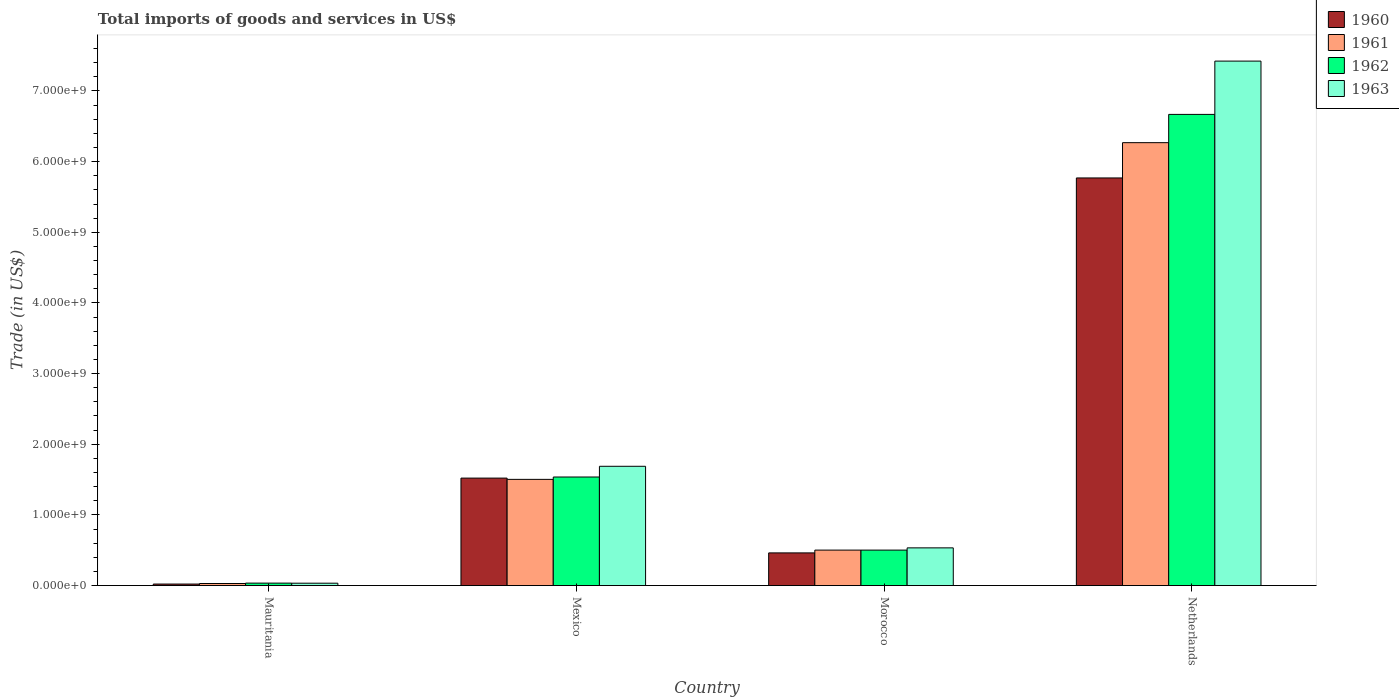How many different coloured bars are there?
Your answer should be compact. 4. How many groups of bars are there?
Your answer should be very brief. 4. Are the number of bars per tick equal to the number of legend labels?
Provide a short and direct response. Yes. Are the number of bars on each tick of the X-axis equal?
Offer a terse response. Yes. How many bars are there on the 2nd tick from the left?
Give a very brief answer. 4. What is the label of the 3rd group of bars from the left?
Provide a short and direct response. Morocco. What is the total imports of goods and services in 1962 in Netherlands?
Your answer should be compact. 6.67e+09. Across all countries, what is the maximum total imports of goods and services in 1963?
Make the answer very short. 7.42e+09. Across all countries, what is the minimum total imports of goods and services in 1962?
Your answer should be compact. 3.46e+07. In which country was the total imports of goods and services in 1961 minimum?
Give a very brief answer. Mauritania. What is the total total imports of goods and services in 1960 in the graph?
Make the answer very short. 7.77e+09. What is the difference between the total imports of goods and services in 1960 in Mauritania and that in Netherlands?
Provide a succinct answer. -5.75e+09. What is the difference between the total imports of goods and services in 1961 in Mauritania and the total imports of goods and services in 1960 in Netherlands?
Your answer should be very brief. -5.74e+09. What is the average total imports of goods and services in 1961 per country?
Your response must be concise. 2.08e+09. What is the difference between the total imports of goods and services of/in 1963 and total imports of goods and services of/in 1960 in Netherlands?
Offer a terse response. 1.65e+09. What is the ratio of the total imports of goods and services in 1963 in Morocco to that in Netherlands?
Ensure brevity in your answer.  0.07. Is the total imports of goods and services in 1961 in Mexico less than that in Netherlands?
Your response must be concise. Yes. Is the difference between the total imports of goods and services in 1963 in Mexico and Morocco greater than the difference between the total imports of goods and services in 1960 in Mexico and Morocco?
Keep it short and to the point. Yes. What is the difference between the highest and the second highest total imports of goods and services in 1963?
Offer a very short reply. -1.15e+09. What is the difference between the highest and the lowest total imports of goods and services in 1961?
Provide a succinct answer. 6.24e+09. In how many countries, is the total imports of goods and services in 1961 greater than the average total imports of goods and services in 1961 taken over all countries?
Keep it short and to the point. 1. How many bars are there?
Offer a very short reply. 16. Are all the bars in the graph horizontal?
Make the answer very short. No. How many countries are there in the graph?
Offer a very short reply. 4. What is the difference between two consecutive major ticks on the Y-axis?
Ensure brevity in your answer.  1.00e+09. What is the title of the graph?
Offer a terse response. Total imports of goods and services in US$. What is the label or title of the X-axis?
Keep it short and to the point. Country. What is the label or title of the Y-axis?
Provide a short and direct response. Trade (in US$). What is the Trade (in US$) in 1960 in Mauritania?
Offer a very short reply. 2.13e+07. What is the Trade (in US$) in 1961 in Mauritania?
Your answer should be compact. 2.91e+07. What is the Trade (in US$) in 1962 in Mauritania?
Keep it short and to the point. 3.46e+07. What is the Trade (in US$) of 1963 in Mauritania?
Ensure brevity in your answer.  3.36e+07. What is the Trade (in US$) in 1960 in Mexico?
Give a very brief answer. 1.52e+09. What is the Trade (in US$) in 1961 in Mexico?
Provide a short and direct response. 1.50e+09. What is the Trade (in US$) of 1962 in Mexico?
Your answer should be compact. 1.54e+09. What is the Trade (in US$) of 1963 in Mexico?
Your response must be concise. 1.69e+09. What is the Trade (in US$) of 1960 in Morocco?
Keep it short and to the point. 4.62e+08. What is the Trade (in US$) of 1961 in Morocco?
Ensure brevity in your answer.  5.02e+08. What is the Trade (in US$) of 1962 in Morocco?
Make the answer very short. 5.02e+08. What is the Trade (in US$) in 1963 in Morocco?
Offer a very short reply. 5.34e+08. What is the Trade (in US$) in 1960 in Netherlands?
Your answer should be compact. 5.77e+09. What is the Trade (in US$) in 1961 in Netherlands?
Provide a succinct answer. 6.27e+09. What is the Trade (in US$) of 1962 in Netherlands?
Ensure brevity in your answer.  6.67e+09. What is the Trade (in US$) in 1963 in Netherlands?
Give a very brief answer. 7.42e+09. Across all countries, what is the maximum Trade (in US$) of 1960?
Your response must be concise. 5.77e+09. Across all countries, what is the maximum Trade (in US$) in 1961?
Your response must be concise. 6.27e+09. Across all countries, what is the maximum Trade (in US$) in 1962?
Your answer should be very brief. 6.67e+09. Across all countries, what is the maximum Trade (in US$) of 1963?
Give a very brief answer. 7.42e+09. Across all countries, what is the minimum Trade (in US$) in 1960?
Offer a terse response. 2.13e+07. Across all countries, what is the minimum Trade (in US$) of 1961?
Provide a succinct answer. 2.91e+07. Across all countries, what is the minimum Trade (in US$) of 1962?
Give a very brief answer. 3.46e+07. Across all countries, what is the minimum Trade (in US$) in 1963?
Your response must be concise. 3.36e+07. What is the total Trade (in US$) in 1960 in the graph?
Give a very brief answer. 7.77e+09. What is the total Trade (in US$) of 1961 in the graph?
Your answer should be very brief. 8.30e+09. What is the total Trade (in US$) in 1962 in the graph?
Your answer should be very brief. 8.74e+09. What is the total Trade (in US$) in 1963 in the graph?
Give a very brief answer. 9.68e+09. What is the difference between the Trade (in US$) of 1960 in Mauritania and that in Mexico?
Provide a succinct answer. -1.50e+09. What is the difference between the Trade (in US$) of 1961 in Mauritania and that in Mexico?
Offer a terse response. -1.47e+09. What is the difference between the Trade (in US$) of 1962 in Mauritania and that in Mexico?
Your response must be concise. -1.50e+09. What is the difference between the Trade (in US$) in 1963 in Mauritania and that in Mexico?
Give a very brief answer. -1.65e+09. What is the difference between the Trade (in US$) in 1960 in Mauritania and that in Morocco?
Provide a succinct answer. -4.41e+08. What is the difference between the Trade (in US$) in 1961 in Mauritania and that in Morocco?
Offer a very short reply. -4.73e+08. What is the difference between the Trade (in US$) of 1962 in Mauritania and that in Morocco?
Provide a short and direct response. -4.67e+08. What is the difference between the Trade (in US$) in 1963 in Mauritania and that in Morocco?
Provide a short and direct response. -5.00e+08. What is the difference between the Trade (in US$) of 1960 in Mauritania and that in Netherlands?
Your response must be concise. -5.75e+09. What is the difference between the Trade (in US$) of 1961 in Mauritania and that in Netherlands?
Ensure brevity in your answer.  -6.24e+09. What is the difference between the Trade (in US$) of 1962 in Mauritania and that in Netherlands?
Provide a succinct answer. -6.63e+09. What is the difference between the Trade (in US$) of 1963 in Mauritania and that in Netherlands?
Make the answer very short. -7.39e+09. What is the difference between the Trade (in US$) of 1960 in Mexico and that in Morocco?
Your response must be concise. 1.06e+09. What is the difference between the Trade (in US$) of 1961 in Mexico and that in Morocco?
Your response must be concise. 1.00e+09. What is the difference between the Trade (in US$) in 1962 in Mexico and that in Morocco?
Make the answer very short. 1.03e+09. What is the difference between the Trade (in US$) of 1963 in Mexico and that in Morocco?
Provide a succinct answer. 1.15e+09. What is the difference between the Trade (in US$) in 1960 in Mexico and that in Netherlands?
Make the answer very short. -4.25e+09. What is the difference between the Trade (in US$) of 1961 in Mexico and that in Netherlands?
Offer a terse response. -4.77e+09. What is the difference between the Trade (in US$) in 1962 in Mexico and that in Netherlands?
Make the answer very short. -5.13e+09. What is the difference between the Trade (in US$) of 1963 in Mexico and that in Netherlands?
Ensure brevity in your answer.  -5.74e+09. What is the difference between the Trade (in US$) of 1960 in Morocco and that in Netherlands?
Your answer should be very brief. -5.31e+09. What is the difference between the Trade (in US$) in 1961 in Morocco and that in Netherlands?
Offer a very short reply. -5.77e+09. What is the difference between the Trade (in US$) of 1962 in Morocco and that in Netherlands?
Ensure brevity in your answer.  -6.17e+09. What is the difference between the Trade (in US$) of 1963 in Morocco and that in Netherlands?
Offer a very short reply. -6.89e+09. What is the difference between the Trade (in US$) of 1960 in Mauritania and the Trade (in US$) of 1961 in Mexico?
Ensure brevity in your answer.  -1.48e+09. What is the difference between the Trade (in US$) in 1960 in Mauritania and the Trade (in US$) in 1962 in Mexico?
Offer a terse response. -1.52e+09. What is the difference between the Trade (in US$) of 1960 in Mauritania and the Trade (in US$) of 1963 in Mexico?
Provide a succinct answer. -1.67e+09. What is the difference between the Trade (in US$) of 1961 in Mauritania and the Trade (in US$) of 1962 in Mexico?
Offer a terse response. -1.51e+09. What is the difference between the Trade (in US$) of 1961 in Mauritania and the Trade (in US$) of 1963 in Mexico?
Keep it short and to the point. -1.66e+09. What is the difference between the Trade (in US$) of 1962 in Mauritania and the Trade (in US$) of 1963 in Mexico?
Offer a terse response. -1.65e+09. What is the difference between the Trade (in US$) in 1960 in Mauritania and the Trade (in US$) in 1961 in Morocco?
Your answer should be very brief. -4.81e+08. What is the difference between the Trade (in US$) in 1960 in Mauritania and the Trade (in US$) in 1962 in Morocco?
Keep it short and to the point. -4.81e+08. What is the difference between the Trade (in US$) of 1960 in Mauritania and the Trade (in US$) of 1963 in Morocco?
Your response must be concise. -5.12e+08. What is the difference between the Trade (in US$) in 1961 in Mauritania and the Trade (in US$) in 1962 in Morocco?
Your answer should be very brief. -4.73e+08. What is the difference between the Trade (in US$) in 1961 in Mauritania and the Trade (in US$) in 1963 in Morocco?
Your answer should be compact. -5.04e+08. What is the difference between the Trade (in US$) of 1962 in Mauritania and the Trade (in US$) of 1963 in Morocco?
Give a very brief answer. -4.99e+08. What is the difference between the Trade (in US$) of 1960 in Mauritania and the Trade (in US$) of 1961 in Netherlands?
Keep it short and to the point. -6.25e+09. What is the difference between the Trade (in US$) in 1960 in Mauritania and the Trade (in US$) in 1962 in Netherlands?
Provide a succinct answer. -6.65e+09. What is the difference between the Trade (in US$) in 1960 in Mauritania and the Trade (in US$) in 1963 in Netherlands?
Offer a very short reply. -7.40e+09. What is the difference between the Trade (in US$) of 1961 in Mauritania and the Trade (in US$) of 1962 in Netherlands?
Keep it short and to the point. -6.64e+09. What is the difference between the Trade (in US$) in 1961 in Mauritania and the Trade (in US$) in 1963 in Netherlands?
Provide a short and direct response. -7.39e+09. What is the difference between the Trade (in US$) of 1962 in Mauritania and the Trade (in US$) of 1963 in Netherlands?
Your answer should be compact. -7.39e+09. What is the difference between the Trade (in US$) in 1960 in Mexico and the Trade (in US$) in 1961 in Morocco?
Your answer should be very brief. 1.02e+09. What is the difference between the Trade (in US$) of 1960 in Mexico and the Trade (in US$) of 1962 in Morocco?
Your answer should be very brief. 1.02e+09. What is the difference between the Trade (in US$) of 1960 in Mexico and the Trade (in US$) of 1963 in Morocco?
Offer a very short reply. 9.87e+08. What is the difference between the Trade (in US$) of 1961 in Mexico and the Trade (in US$) of 1962 in Morocco?
Provide a succinct answer. 1.00e+09. What is the difference between the Trade (in US$) of 1961 in Mexico and the Trade (in US$) of 1963 in Morocco?
Your response must be concise. 9.70e+08. What is the difference between the Trade (in US$) of 1962 in Mexico and the Trade (in US$) of 1963 in Morocco?
Keep it short and to the point. 1.00e+09. What is the difference between the Trade (in US$) of 1960 in Mexico and the Trade (in US$) of 1961 in Netherlands?
Ensure brevity in your answer.  -4.75e+09. What is the difference between the Trade (in US$) in 1960 in Mexico and the Trade (in US$) in 1962 in Netherlands?
Provide a succinct answer. -5.15e+09. What is the difference between the Trade (in US$) in 1960 in Mexico and the Trade (in US$) in 1963 in Netherlands?
Provide a short and direct response. -5.90e+09. What is the difference between the Trade (in US$) of 1961 in Mexico and the Trade (in US$) of 1962 in Netherlands?
Provide a succinct answer. -5.17e+09. What is the difference between the Trade (in US$) in 1961 in Mexico and the Trade (in US$) in 1963 in Netherlands?
Offer a very short reply. -5.92e+09. What is the difference between the Trade (in US$) in 1962 in Mexico and the Trade (in US$) in 1963 in Netherlands?
Provide a succinct answer. -5.89e+09. What is the difference between the Trade (in US$) in 1960 in Morocco and the Trade (in US$) in 1961 in Netherlands?
Make the answer very short. -5.81e+09. What is the difference between the Trade (in US$) in 1960 in Morocco and the Trade (in US$) in 1962 in Netherlands?
Give a very brief answer. -6.21e+09. What is the difference between the Trade (in US$) of 1960 in Morocco and the Trade (in US$) of 1963 in Netherlands?
Offer a very short reply. -6.96e+09. What is the difference between the Trade (in US$) of 1961 in Morocco and the Trade (in US$) of 1962 in Netherlands?
Give a very brief answer. -6.17e+09. What is the difference between the Trade (in US$) of 1961 in Morocco and the Trade (in US$) of 1963 in Netherlands?
Offer a very short reply. -6.92e+09. What is the difference between the Trade (in US$) of 1962 in Morocco and the Trade (in US$) of 1963 in Netherlands?
Provide a succinct answer. -6.92e+09. What is the average Trade (in US$) in 1960 per country?
Offer a very short reply. 1.94e+09. What is the average Trade (in US$) of 1961 per country?
Offer a terse response. 2.08e+09. What is the average Trade (in US$) of 1962 per country?
Ensure brevity in your answer.  2.19e+09. What is the average Trade (in US$) of 1963 per country?
Your answer should be very brief. 2.42e+09. What is the difference between the Trade (in US$) of 1960 and Trade (in US$) of 1961 in Mauritania?
Offer a terse response. -7.84e+06. What is the difference between the Trade (in US$) of 1960 and Trade (in US$) of 1962 in Mauritania?
Make the answer very short. -1.33e+07. What is the difference between the Trade (in US$) in 1960 and Trade (in US$) in 1963 in Mauritania?
Ensure brevity in your answer.  -1.23e+07. What is the difference between the Trade (in US$) of 1961 and Trade (in US$) of 1962 in Mauritania?
Provide a succinct answer. -5.42e+06. What is the difference between the Trade (in US$) in 1961 and Trade (in US$) in 1963 in Mauritania?
Provide a short and direct response. -4.48e+06. What is the difference between the Trade (in US$) in 1962 and Trade (in US$) in 1963 in Mauritania?
Your response must be concise. 9.34e+05. What is the difference between the Trade (in US$) in 1960 and Trade (in US$) in 1961 in Mexico?
Give a very brief answer. 1.78e+07. What is the difference between the Trade (in US$) of 1960 and Trade (in US$) of 1962 in Mexico?
Your answer should be very brief. -1.56e+07. What is the difference between the Trade (in US$) of 1960 and Trade (in US$) of 1963 in Mexico?
Your answer should be very brief. -1.67e+08. What is the difference between the Trade (in US$) of 1961 and Trade (in US$) of 1962 in Mexico?
Provide a succinct answer. -3.34e+07. What is the difference between the Trade (in US$) in 1961 and Trade (in US$) in 1963 in Mexico?
Provide a succinct answer. -1.85e+08. What is the difference between the Trade (in US$) in 1962 and Trade (in US$) in 1963 in Mexico?
Offer a very short reply. -1.52e+08. What is the difference between the Trade (in US$) in 1960 and Trade (in US$) in 1961 in Morocco?
Your answer should be very brief. -3.95e+07. What is the difference between the Trade (in US$) of 1960 and Trade (in US$) of 1962 in Morocco?
Offer a very short reply. -3.95e+07. What is the difference between the Trade (in US$) in 1960 and Trade (in US$) in 1963 in Morocco?
Provide a succinct answer. -7.11e+07. What is the difference between the Trade (in US$) in 1961 and Trade (in US$) in 1962 in Morocco?
Give a very brief answer. 0. What is the difference between the Trade (in US$) in 1961 and Trade (in US$) in 1963 in Morocco?
Give a very brief answer. -3.16e+07. What is the difference between the Trade (in US$) in 1962 and Trade (in US$) in 1963 in Morocco?
Provide a succinct answer. -3.16e+07. What is the difference between the Trade (in US$) in 1960 and Trade (in US$) in 1961 in Netherlands?
Offer a very short reply. -4.99e+08. What is the difference between the Trade (in US$) in 1960 and Trade (in US$) in 1962 in Netherlands?
Your answer should be compact. -8.99e+08. What is the difference between the Trade (in US$) in 1960 and Trade (in US$) in 1963 in Netherlands?
Offer a terse response. -1.65e+09. What is the difference between the Trade (in US$) in 1961 and Trade (in US$) in 1962 in Netherlands?
Give a very brief answer. -4.00e+08. What is the difference between the Trade (in US$) in 1961 and Trade (in US$) in 1963 in Netherlands?
Make the answer very short. -1.15e+09. What is the difference between the Trade (in US$) in 1962 and Trade (in US$) in 1963 in Netherlands?
Your response must be concise. -7.54e+08. What is the ratio of the Trade (in US$) of 1960 in Mauritania to that in Mexico?
Provide a succinct answer. 0.01. What is the ratio of the Trade (in US$) in 1961 in Mauritania to that in Mexico?
Your response must be concise. 0.02. What is the ratio of the Trade (in US$) in 1962 in Mauritania to that in Mexico?
Give a very brief answer. 0.02. What is the ratio of the Trade (in US$) in 1963 in Mauritania to that in Mexico?
Your answer should be very brief. 0.02. What is the ratio of the Trade (in US$) in 1960 in Mauritania to that in Morocco?
Your answer should be compact. 0.05. What is the ratio of the Trade (in US$) of 1961 in Mauritania to that in Morocco?
Your response must be concise. 0.06. What is the ratio of the Trade (in US$) in 1962 in Mauritania to that in Morocco?
Provide a short and direct response. 0.07. What is the ratio of the Trade (in US$) in 1963 in Mauritania to that in Morocco?
Make the answer very short. 0.06. What is the ratio of the Trade (in US$) in 1960 in Mauritania to that in Netherlands?
Keep it short and to the point. 0. What is the ratio of the Trade (in US$) in 1961 in Mauritania to that in Netherlands?
Make the answer very short. 0. What is the ratio of the Trade (in US$) in 1962 in Mauritania to that in Netherlands?
Ensure brevity in your answer.  0.01. What is the ratio of the Trade (in US$) in 1963 in Mauritania to that in Netherlands?
Your answer should be very brief. 0. What is the ratio of the Trade (in US$) of 1960 in Mexico to that in Morocco?
Keep it short and to the point. 3.29. What is the ratio of the Trade (in US$) in 1961 in Mexico to that in Morocco?
Your response must be concise. 2.99. What is the ratio of the Trade (in US$) of 1962 in Mexico to that in Morocco?
Your response must be concise. 3.06. What is the ratio of the Trade (in US$) of 1963 in Mexico to that in Morocco?
Keep it short and to the point. 3.16. What is the ratio of the Trade (in US$) in 1960 in Mexico to that in Netherlands?
Your response must be concise. 0.26. What is the ratio of the Trade (in US$) in 1961 in Mexico to that in Netherlands?
Your answer should be very brief. 0.24. What is the ratio of the Trade (in US$) in 1962 in Mexico to that in Netherlands?
Ensure brevity in your answer.  0.23. What is the ratio of the Trade (in US$) of 1963 in Mexico to that in Netherlands?
Your response must be concise. 0.23. What is the ratio of the Trade (in US$) in 1960 in Morocco to that in Netherlands?
Provide a succinct answer. 0.08. What is the ratio of the Trade (in US$) of 1961 in Morocco to that in Netherlands?
Provide a succinct answer. 0.08. What is the ratio of the Trade (in US$) in 1962 in Morocco to that in Netherlands?
Offer a terse response. 0.08. What is the ratio of the Trade (in US$) in 1963 in Morocco to that in Netherlands?
Offer a terse response. 0.07. What is the difference between the highest and the second highest Trade (in US$) of 1960?
Your answer should be very brief. 4.25e+09. What is the difference between the highest and the second highest Trade (in US$) in 1961?
Make the answer very short. 4.77e+09. What is the difference between the highest and the second highest Trade (in US$) of 1962?
Your answer should be compact. 5.13e+09. What is the difference between the highest and the second highest Trade (in US$) of 1963?
Your response must be concise. 5.74e+09. What is the difference between the highest and the lowest Trade (in US$) of 1960?
Offer a very short reply. 5.75e+09. What is the difference between the highest and the lowest Trade (in US$) of 1961?
Provide a succinct answer. 6.24e+09. What is the difference between the highest and the lowest Trade (in US$) in 1962?
Your response must be concise. 6.63e+09. What is the difference between the highest and the lowest Trade (in US$) of 1963?
Ensure brevity in your answer.  7.39e+09. 